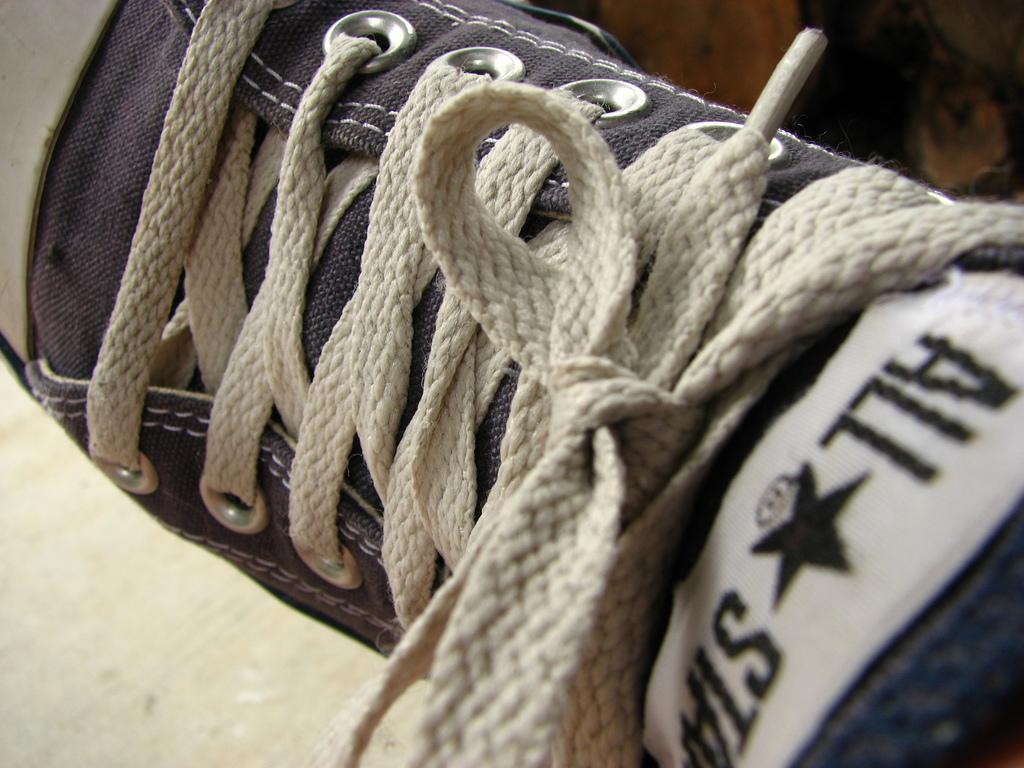In one or two sentences, can you explain what this image depicts? In this image there is a shoe. There are shoelaces tied to the shoe. In the bottom right there is text on the show. In between the text there is a star symbol. 